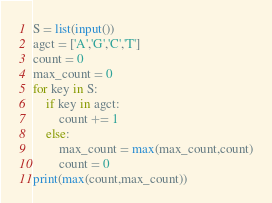<code> <loc_0><loc_0><loc_500><loc_500><_Python_>S = list(input())
agct = ['A','G','C','T']
count = 0
max_count = 0
for key in S:
    if key in agct:
        count += 1
    else:
        max_count = max(max_count,count)
        count = 0
print(max(count,max_count))</code> 